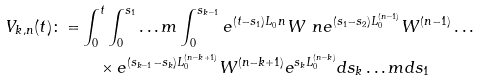<formula> <loc_0><loc_0><loc_500><loc_500>V _ { k , n } ( t ) \colon = & \int _ { 0 } ^ { t } \int _ { 0 } ^ { s _ { 1 } } \dots m \int _ { 0 } ^ { s _ { k - 1 } } e ^ { ( t - s _ { 1 } ) L _ { 0 } ^ { \ } n } W ^ { \ } n e ^ { ( s _ { 1 } - s _ { 2 } ) L _ { 0 } ^ { ( n - 1 ) } } W ^ { ( n - 1 ) } \dots \\ & \quad \times e ^ { ( s _ { k - 1 } - s _ { k } ) L _ { 0 } ^ { ( n - k + 1 ) } } W ^ { ( n - k + 1 ) } e ^ { s _ { k } L _ { 0 } ^ { ( n - k ) } } d s _ { k } \dots m d s _ { 1 }</formula> 